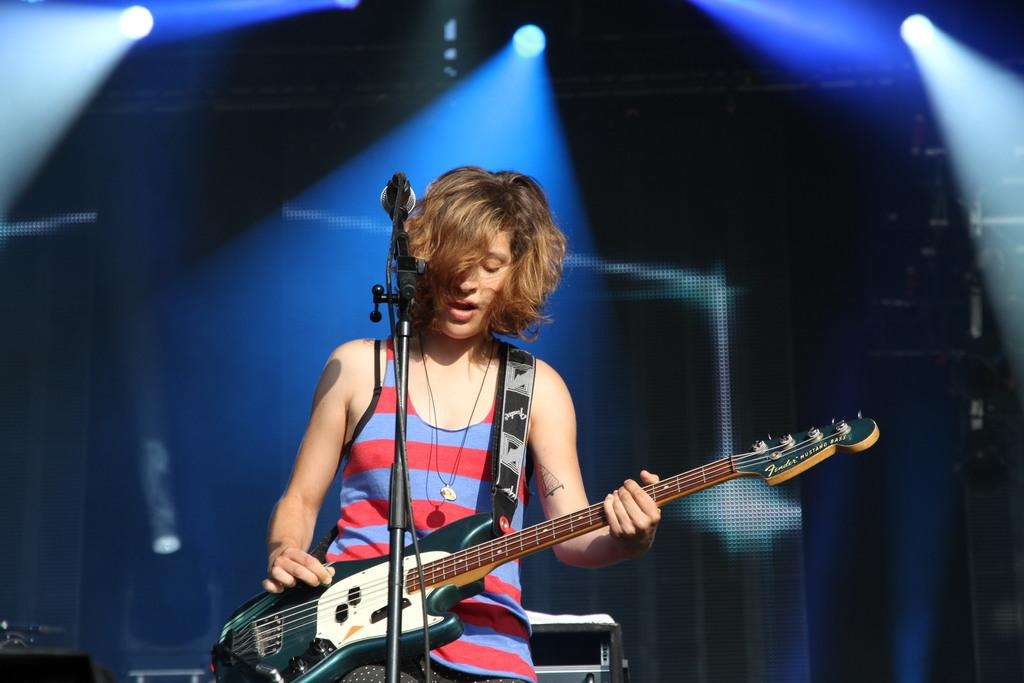Who is the main subject in the image? There is a woman in the image. What is the woman doing in the image? The woman is standing, singing, and holding a microphone and a guitar. What can be seen in the background of the image? There are lights in the background of the image. What type of cakes can be seen on the stage in the image? There are no cakes present in the image; the woman is holding a microphone and a guitar while singing. What type of pleasure does the woman experience while performing in the image? The image does not provide information about the woman's emotions or feelings, so it is impossible to determine the type of pleasure she may be experiencing. 